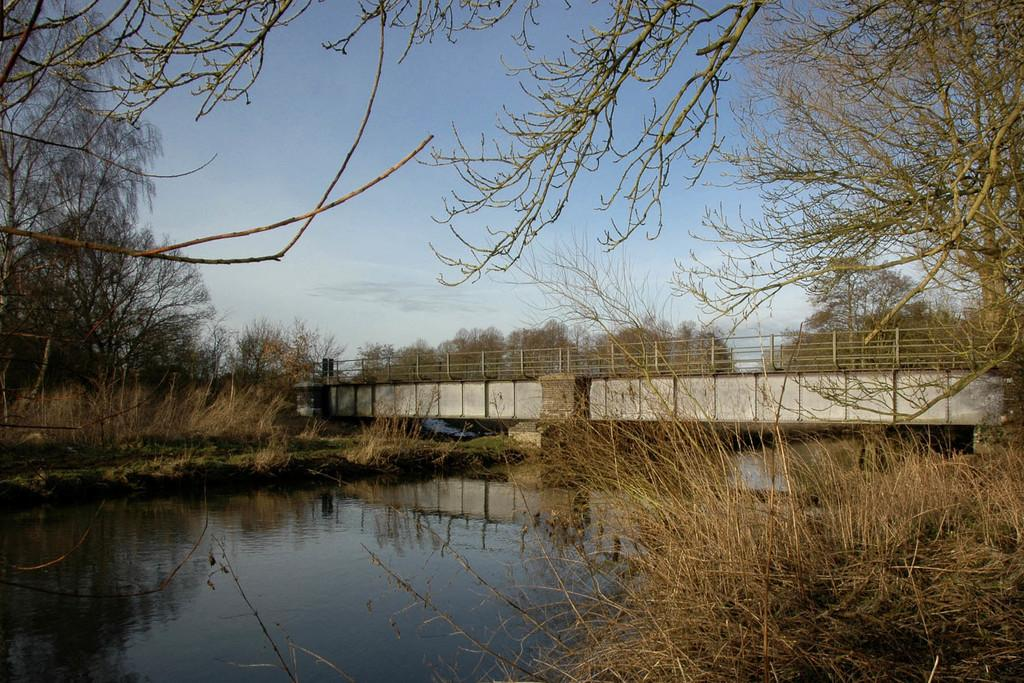What type of living organisms can be seen in the image? Plants and trees are visible in the image. What is the primary element in the image? Water is visible in the image. What type of structure can be seen in the image? There is a bridge in the image. What type of barrier is present in the image? There are fences in the image. What is visible in the background of the image? The sky is visible in the background of the image. What type of ocean can be seen in the image? There is no ocean present in the image; it features plants, water, a bridge, fences, trees, and the sky. What type of system is responsible for the operation of the bridge in the image? The image does not provide information about the bridge's operation or any system responsible for it. 